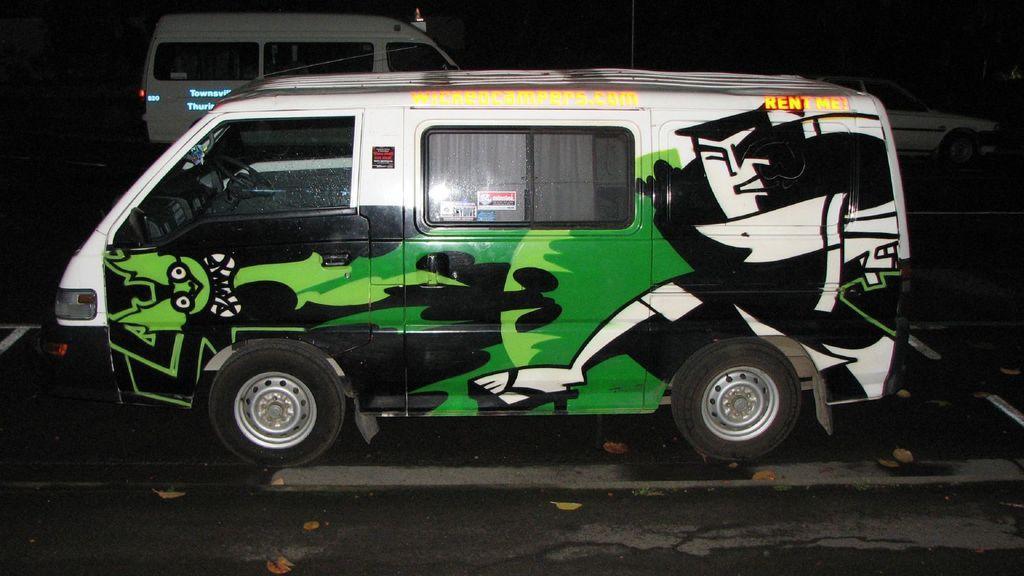How would you summarize this image in a sentence or two? In this image we can see motor vehicles on the road. 